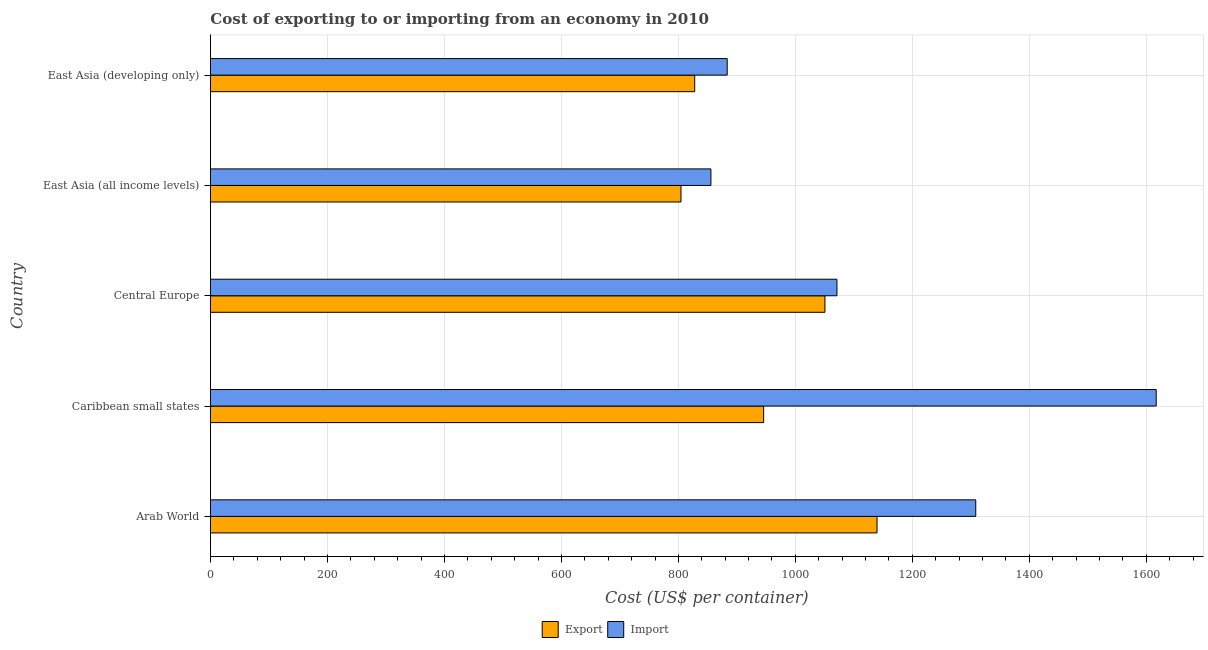How many groups of bars are there?
Give a very brief answer. 5. How many bars are there on the 3rd tick from the top?
Provide a succinct answer. 2. How many bars are there on the 1st tick from the bottom?
Provide a short and direct response. 2. What is the label of the 4th group of bars from the top?
Ensure brevity in your answer.  Caribbean small states. In how many cases, is the number of bars for a given country not equal to the number of legend labels?
Your response must be concise. 0. What is the export cost in East Asia (developing only)?
Provide a succinct answer. 827.9. Across all countries, what is the maximum export cost?
Offer a terse response. 1139.6. Across all countries, what is the minimum export cost?
Your answer should be compact. 804.43. In which country was the export cost maximum?
Provide a short and direct response. Arab World. In which country was the export cost minimum?
Your answer should be very brief. East Asia (all income levels). What is the total export cost in the graph?
Provide a short and direct response. 4768.22. What is the difference between the export cost in Arab World and that in East Asia (developing only)?
Give a very brief answer. 311.7. What is the difference between the export cost in Central Europe and the import cost in Caribbean small states?
Your answer should be compact. -566.37. What is the average import cost per country?
Your response must be concise. 1147.09. What is the difference between the export cost and import cost in Arab World?
Your answer should be very brief. -168.8. What is the ratio of the import cost in Caribbean small states to that in Central Europe?
Your answer should be compact. 1.51. Is the difference between the import cost in Arab World and Caribbean small states greater than the difference between the export cost in Arab World and Caribbean small states?
Make the answer very short. No. What is the difference between the highest and the second highest export cost?
Offer a terse response. 89.06. What is the difference between the highest and the lowest import cost?
Ensure brevity in your answer.  761.31. In how many countries, is the import cost greater than the average import cost taken over all countries?
Offer a very short reply. 2. Is the sum of the import cost in Arab World and Central Europe greater than the maximum export cost across all countries?
Your answer should be very brief. Yes. What does the 2nd bar from the top in East Asia (developing only) represents?
Provide a succinct answer. Export. What does the 2nd bar from the bottom in Caribbean small states represents?
Provide a succinct answer. Import. Are all the bars in the graph horizontal?
Give a very brief answer. Yes. What is the difference between two consecutive major ticks on the X-axis?
Offer a very short reply. 200. Are the values on the major ticks of X-axis written in scientific E-notation?
Offer a very short reply. No. Does the graph contain grids?
Your answer should be very brief. Yes. How many legend labels are there?
Your response must be concise. 2. What is the title of the graph?
Offer a very short reply. Cost of exporting to or importing from an economy in 2010. What is the label or title of the X-axis?
Offer a very short reply. Cost (US$ per container). What is the Cost (US$ per container) of Export in Arab World?
Make the answer very short. 1139.6. What is the Cost (US$ per container) in Import in Arab World?
Your response must be concise. 1308.4. What is the Cost (US$ per container) of Export in Caribbean small states?
Give a very brief answer. 945.75. What is the Cost (US$ per container) in Import in Caribbean small states?
Make the answer very short. 1616.92. What is the Cost (US$ per container) in Export in Central Europe?
Your answer should be very brief. 1050.55. What is the Cost (US$ per container) in Import in Central Europe?
Your answer should be very brief. 1071.09. What is the Cost (US$ per container) of Export in East Asia (all income levels)?
Keep it short and to the point. 804.43. What is the Cost (US$ per container) in Import in East Asia (all income levels)?
Make the answer very short. 855.61. What is the Cost (US$ per container) of Export in East Asia (developing only)?
Provide a short and direct response. 827.9. What is the Cost (US$ per container) of Import in East Asia (developing only)?
Your response must be concise. 883.45. Across all countries, what is the maximum Cost (US$ per container) of Export?
Offer a very short reply. 1139.6. Across all countries, what is the maximum Cost (US$ per container) in Import?
Offer a terse response. 1616.92. Across all countries, what is the minimum Cost (US$ per container) of Export?
Provide a succinct answer. 804.43. Across all countries, what is the minimum Cost (US$ per container) in Import?
Ensure brevity in your answer.  855.61. What is the total Cost (US$ per container) in Export in the graph?
Give a very brief answer. 4768.22. What is the total Cost (US$ per container) in Import in the graph?
Provide a succinct answer. 5735.46. What is the difference between the Cost (US$ per container) of Export in Arab World and that in Caribbean small states?
Provide a short and direct response. 193.85. What is the difference between the Cost (US$ per container) in Import in Arab World and that in Caribbean small states?
Make the answer very short. -308.52. What is the difference between the Cost (US$ per container) of Export in Arab World and that in Central Europe?
Offer a terse response. 89.05. What is the difference between the Cost (US$ per container) in Import in Arab World and that in Central Europe?
Give a very brief answer. 237.31. What is the difference between the Cost (US$ per container) in Export in Arab World and that in East Asia (all income levels)?
Offer a terse response. 335.17. What is the difference between the Cost (US$ per container) of Import in Arab World and that in East Asia (all income levels)?
Give a very brief answer. 452.79. What is the difference between the Cost (US$ per container) in Export in Arab World and that in East Asia (developing only)?
Keep it short and to the point. 311.7. What is the difference between the Cost (US$ per container) in Import in Arab World and that in East Asia (developing only)?
Ensure brevity in your answer.  424.95. What is the difference between the Cost (US$ per container) of Export in Caribbean small states and that in Central Europe?
Give a very brief answer. -104.8. What is the difference between the Cost (US$ per container) of Import in Caribbean small states and that in Central Europe?
Offer a very short reply. 545.83. What is the difference between the Cost (US$ per container) in Export in Caribbean small states and that in East Asia (all income levels)?
Offer a very short reply. 141.32. What is the difference between the Cost (US$ per container) in Import in Caribbean small states and that in East Asia (all income levels)?
Make the answer very short. 761.31. What is the difference between the Cost (US$ per container) of Export in Caribbean small states and that in East Asia (developing only)?
Provide a succinct answer. 117.85. What is the difference between the Cost (US$ per container) in Import in Caribbean small states and that in East Asia (developing only)?
Provide a short and direct response. 733.47. What is the difference between the Cost (US$ per container) of Export in Central Europe and that in East Asia (all income levels)?
Give a very brief answer. 246.12. What is the difference between the Cost (US$ per container) of Import in Central Europe and that in East Asia (all income levels)?
Give a very brief answer. 215.48. What is the difference between the Cost (US$ per container) of Export in Central Europe and that in East Asia (developing only)?
Offer a very short reply. 222.65. What is the difference between the Cost (US$ per container) in Import in Central Europe and that in East Asia (developing only)?
Offer a very short reply. 187.64. What is the difference between the Cost (US$ per container) in Export in East Asia (all income levels) and that in East Asia (developing only)?
Ensure brevity in your answer.  -23.47. What is the difference between the Cost (US$ per container) in Import in East Asia (all income levels) and that in East Asia (developing only)?
Provide a short and direct response. -27.84. What is the difference between the Cost (US$ per container) of Export in Arab World and the Cost (US$ per container) of Import in Caribbean small states?
Make the answer very short. -477.32. What is the difference between the Cost (US$ per container) of Export in Arab World and the Cost (US$ per container) of Import in Central Europe?
Make the answer very short. 68.51. What is the difference between the Cost (US$ per container) of Export in Arab World and the Cost (US$ per container) of Import in East Asia (all income levels)?
Provide a succinct answer. 283.99. What is the difference between the Cost (US$ per container) of Export in Arab World and the Cost (US$ per container) of Import in East Asia (developing only)?
Provide a succinct answer. 256.15. What is the difference between the Cost (US$ per container) in Export in Caribbean small states and the Cost (US$ per container) in Import in Central Europe?
Give a very brief answer. -125.34. What is the difference between the Cost (US$ per container) of Export in Caribbean small states and the Cost (US$ per container) of Import in East Asia (all income levels)?
Provide a short and direct response. 90.14. What is the difference between the Cost (US$ per container) in Export in Caribbean small states and the Cost (US$ per container) in Import in East Asia (developing only)?
Offer a very short reply. 62.3. What is the difference between the Cost (US$ per container) of Export in Central Europe and the Cost (US$ per container) of Import in East Asia (all income levels)?
Provide a short and direct response. 194.94. What is the difference between the Cost (US$ per container) of Export in Central Europe and the Cost (US$ per container) of Import in East Asia (developing only)?
Keep it short and to the point. 167.1. What is the difference between the Cost (US$ per container) of Export in East Asia (all income levels) and the Cost (US$ per container) of Import in East Asia (developing only)?
Keep it short and to the point. -79.02. What is the average Cost (US$ per container) in Export per country?
Provide a short and direct response. 953.64. What is the average Cost (US$ per container) in Import per country?
Give a very brief answer. 1147.09. What is the difference between the Cost (US$ per container) in Export and Cost (US$ per container) in Import in Arab World?
Offer a terse response. -168.8. What is the difference between the Cost (US$ per container) of Export and Cost (US$ per container) of Import in Caribbean small states?
Provide a succinct answer. -671.17. What is the difference between the Cost (US$ per container) of Export and Cost (US$ per container) of Import in Central Europe?
Give a very brief answer. -20.55. What is the difference between the Cost (US$ per container) in Export and Cost (US$ per container) in Import in East Asia (all income levels)?
Offer a terse response. -51.18. What is the difference between the Cost (US$ per container) of Export and Cost (US$ per container) of Import in East Asia (developing only)?
Keep it short and to the point. -55.55. What is the ratio of the Cost (US$ per container) in Export in Arab World to that in Caribbean small states?
Your response must be concise. 1.21. What is the ratio of the Cost (US$ per container) of Import in Arab World to that in Caribbean small states?
Your answer should be compact. 0.81. What is the ratio of the Cost (US$ per container) of Export in Arab World to that in Central Europe?
Provide a succinct answer. 1.08. What is the ratio of the Cost (US$ per container) in Import in Arab World to that in Central Europe?
Ensure brevity in your answer.  1.22. What is the ratio of the Cost (US$ per container) of Export in Arab World to that in East Asia (all income levels)?
Your answer should be very brief. 1.42. What is the ratio of the Cost (US$ per container) in Import in Arab World to that in East Asia (all income levels)?
Provide a short and direct response. 1.53. What is the ratio of the Cost (US$ per container) of Export in Arab World to that in East Asia (developing only)?
Your answer should be compact. 1.38. What is the ratio of the Cost (US$ per container) of Import in Arab World to that in East Asia (developing only)?
Provide a short and direct response. 1.48. What is the ratio of the Cost (US$ per container) of Export in Caribbean small states to that in Central Europe?
Offer a terse response. 0.9. What is the ratio of the Cost (US$ per container) in Import in Caribbean small states to that in Central Europe?
Make the answer very short. 1.51. What is the ratio of the Cost (US$ per container) of Export in Caribbean small states to that in East Asia (all income levels)?
Provide a succinct answer. 1.18. What is the ratio of the Cost (US$ per container) in Import in Caribbean small states to that in East Asia (all income levels)?
Make the answer very short. 1.89. What is the ratio of the Cost (US$ per container) in Export in Caribbean small states to that in East Asia (developing only)?
Offer a very short reply. 1.14. What is the ratio of the Cost (US$ per container) of Import in Caribbean small states to that in East Asia (developing only)?
Keep it short and to the point. 1.83. What is the ratio of the Cost (US$ per container) in Export in Central Europe to that in East Asia (all income levels)?
Provide a succinct answer. 1.31. What is the ratio of the Cost (US$ per container) of Import in Central Europe to that in East Asia (all income levels)?
Your answer should be compact. 1.25. What is the ratio of the Cost (US$ per container) of Export in Central Europe to that in East Asia (developing only)?
Ensure brevity in your answer.  1.27. What is the ratio of the Cost (US$ per container) in Import in Central Europe to that in East Asia (developing only)?
Your response must be concise. 1.21. What is the ratio of the Cost (US$ per container) in Export in East Asia (all income levels) to that in East Asia (developing only)?
Provide a succinct answer. 0.97. What is the ratio of the Cost (US$ per container) of Import in East Asia (all income levels) to that in East Asia (developing only)?
Your response must be concise. 0.97. What is the difference between the highest and the second highest Cost (US$ per container) in Export?
Ensure brevity in your answer.  89.05. What is the difference between the highest and the second highest Cost (US$ per container) of Import?
Your answer should be very brief. 308.52. What is the difference between the highest and the lowest Cost (US$ per container) of Export?
Make the answer very short. 335.17. What is the difference between the highest and the lowest Cost (US$ per container) of Import?
Make the answer very short. 761.31. 